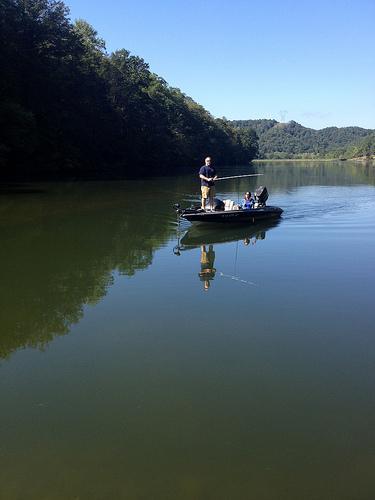How many boats are in the photo?
Give a very brief answer. 1. How many people are on the bus?
Give a very brief answer. 2. 